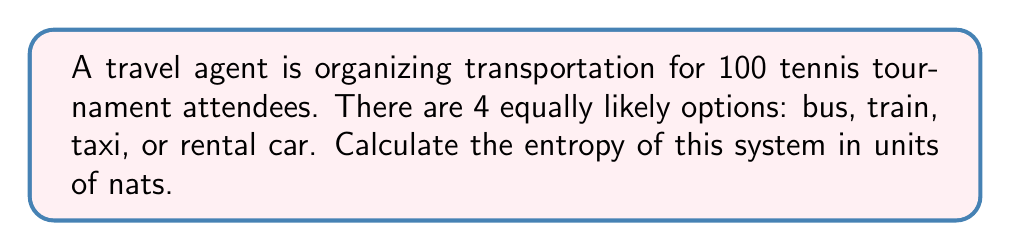Give your solution to this math problem. To solve this problem, we'll follow these steps:

1) The entropy of a system is given by the formula:

   $$S = -k \sum_{i=1}^{n} p_i \ln(p_i)$$

   where $k$ is Boltzmann's constant, $p_i$ is the probability of state $i$, and $n$ is the number of possible states.

2) In this case, we have 4 equally likely options, so $n = 4$ and $p_i = \frac{1}{4}$ for all $i$.

3) We're calculating entropy in nats, so we use natural logarithms and set $k = 1$.

4) Substituting these values into the formula:

   $$S = -1 \cdot \sum_{i=1}^{4} \frac{1}{4} \ln(\frac{1}{4})$$

5) Since all terms in the sum are identical, we can simplify:

   $$S = -4 \cdot \frac{1}{4} \ln(\frac{1}{4}) = -\ln(\frac{1}{4})$$

6) Using the logarithm property $\ln(\frac{1}{x}) = -\ln(x)$:

   $$S = \ln(4)$$

7) Calculate the natural logarithm of 4:

   $$S = \ln(4) \approx 1.3863$$

Thus, the entropy of the system is approximately 1.3863 nats.
Answer: $\ln(4) \approx 1.3863$ nats 